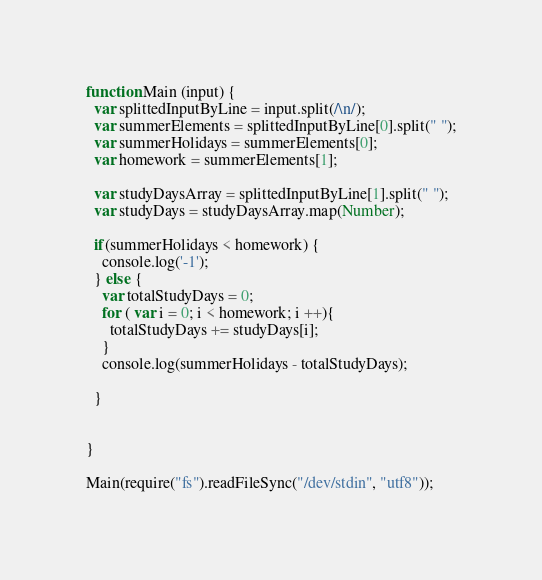Convert code to text. <code><loc_0><loc_0><loc_500><loc_500><_JavaScript_>function Main (input) {
  var splittedInputByLine = input.split(/\n/);
  var summerElements = splittedInputByLine[0].split(" ");
  var summerHolidays = summerElements[0];
  var homework = summerElements[1];
  
  var studyDaysArray = splittedInputByLine[1].split(" ");
  var studyDays = studyDaysArray.map(Number);
      
  if(summerHolidays < homework) {
    console.log('-1');
  } else {
    var totalStudyDays = 0;
    for ( var i = 0; i < homework; i ++){
      totalStudyDays += studyDays[i];
    }
    console.log(summerHolidays - totalStudyDays);
    
  }
  
	
}

Main(require("fs").readFileSync("/dev/stdin", "utf8"));
</code> 